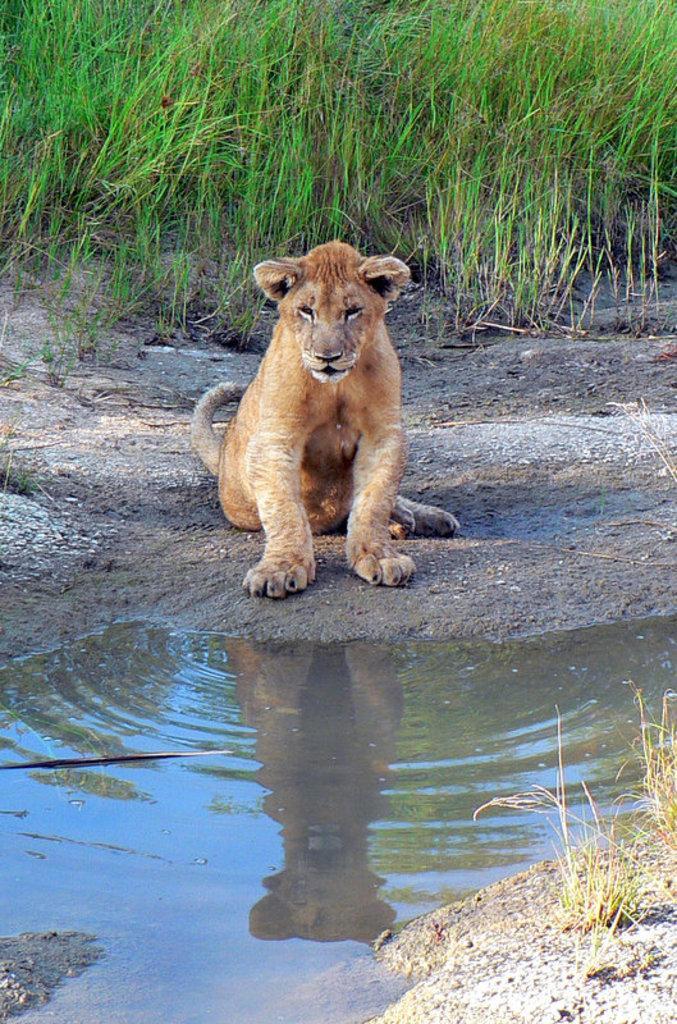Please provide a concise description of this image. In the center of the image, we can see a lion and in the background, there is grass and water. 